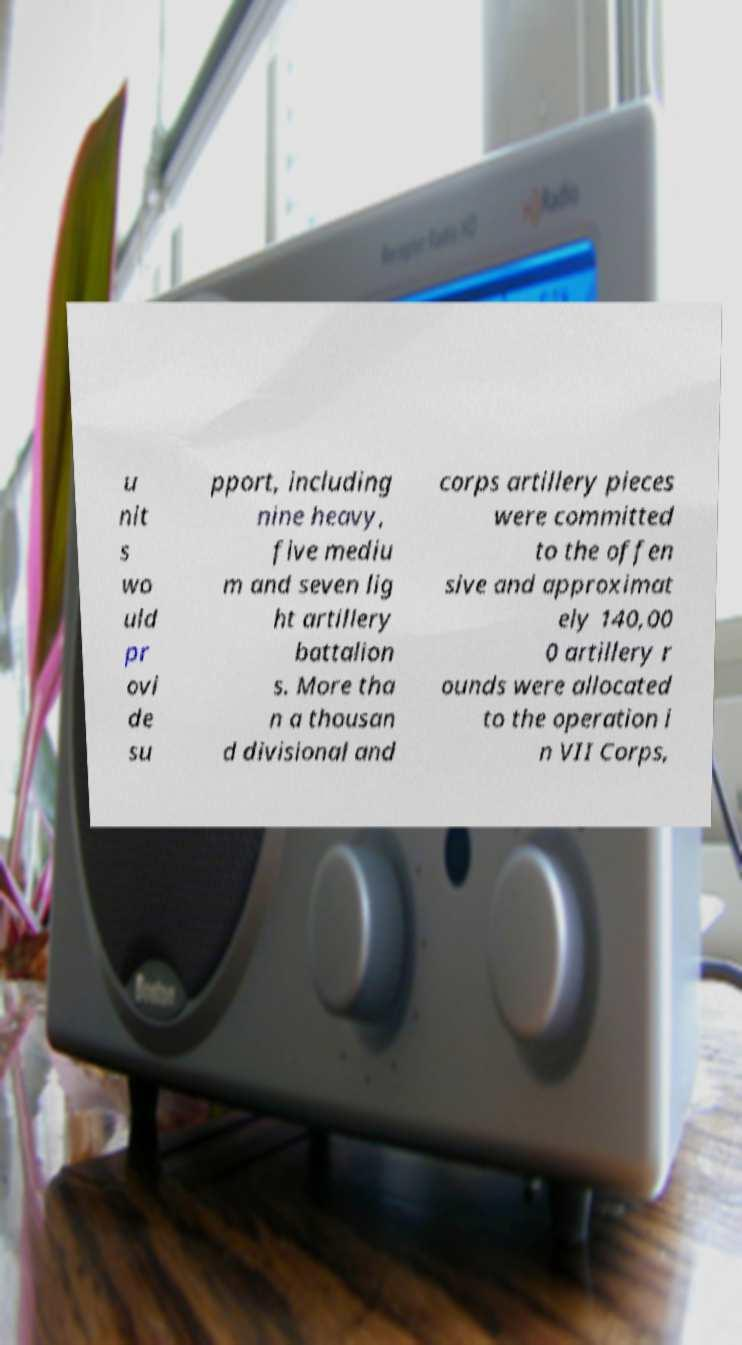Please identify and transcribe the text found in this image. u nit s wo uld pr ovi de su pport, including nine heavy, five mediu m and seven lig ht artillery battalion s. More tha n a thousan d divisional and corps artillery pieces were committed to the offen sive and approximat ely 140,00 0 artillery r ounds were allocated to the operation i n VII Corps, 